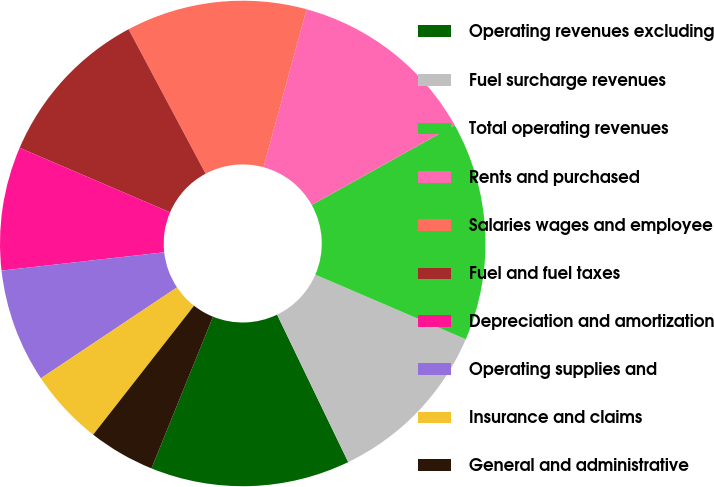Convert chart to OTSL. <chart><loc_0><loc_0><loc_500><loc_500><pie_chart><fcel>Operating revenues excluding<fcel>Fuel surcharge revenues<fcel>Total operating revenues<fcel>Rents and purchased<fcel>Salaries wages and employee<fcel>Fuel and fuel taxes<fcel>Depreciation and amortization<fcel>Operating supplies and<fcel>Insurance and claims<fcel>General and administrative<nl><fcel>13.29%<fcel>11.39%<fcel>14.56%<fcel>12.66%<fcel>12.03%<fcel>10.76%<fcel>8.23%<fcel>7.59%<fcel>5.06%<fcel>4.43%<nl></chart> 